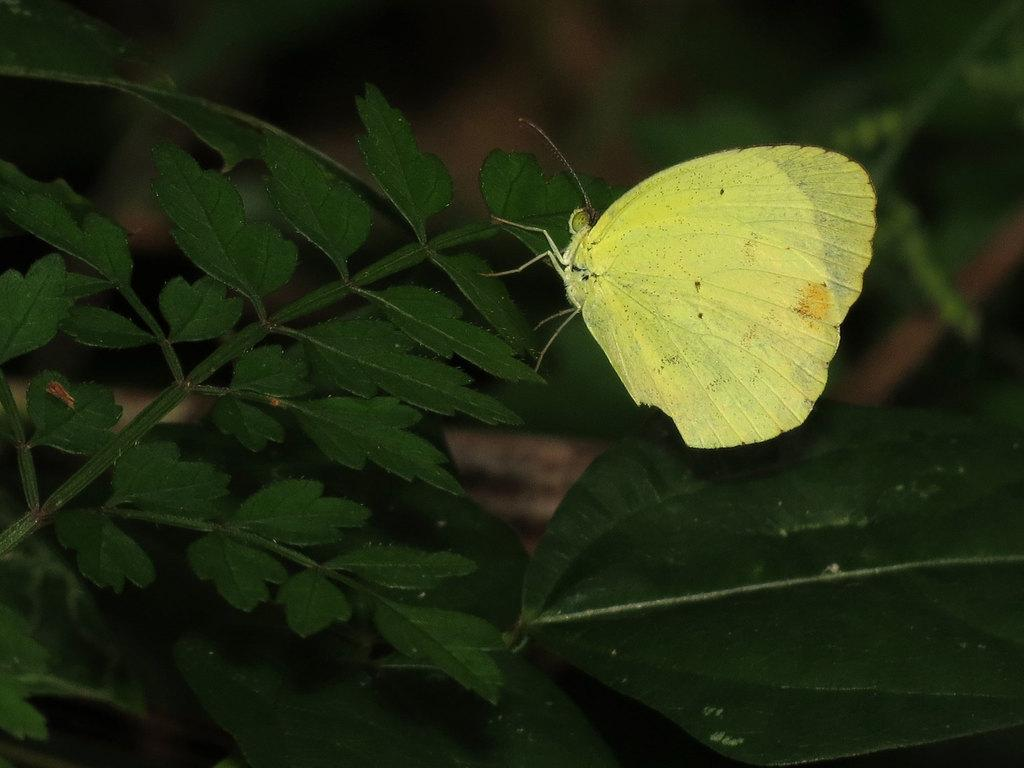What is the main subject of the image? There is a butterfly in the image. Where is the butterfly located? The butterfly is on a leaf. What else can be seen in the image besides the butterfly? There are other leaves visible in the image. How would you describe the background of the image? The background is blurred. What type of drink is being served in the image? There is no drink present in the image; it features a butterfly on a leaf. Is the butterfly framed in the image? The butterfly is not framed in the image; it is on a leaf. 